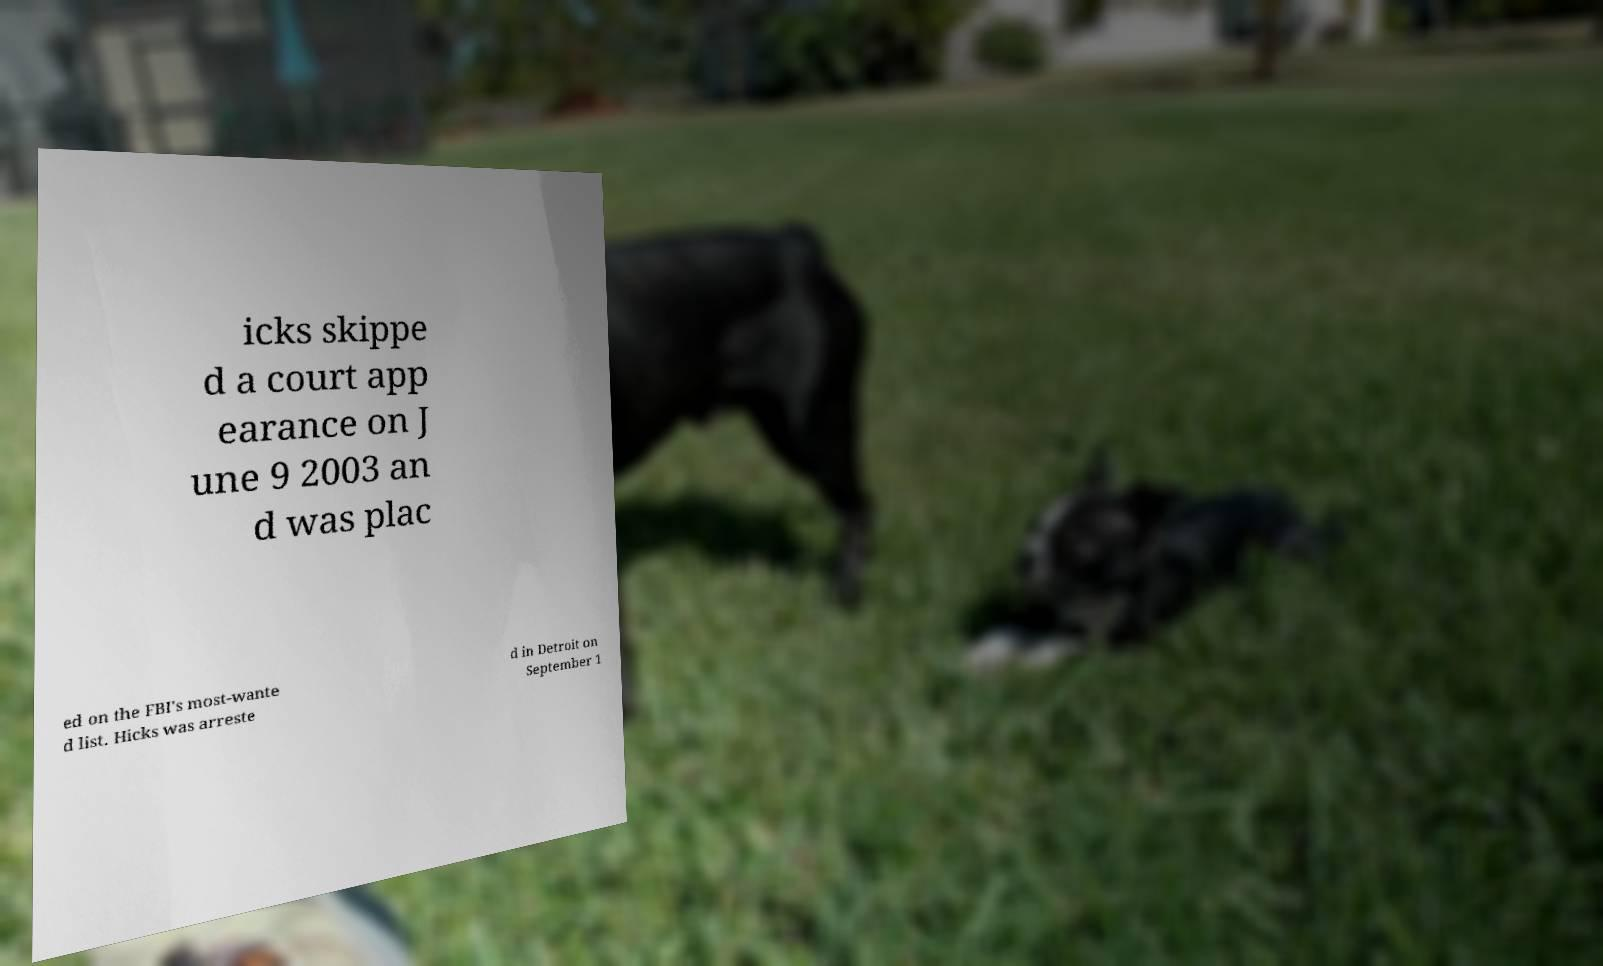Could you assist in decoding the text presented in this image and type it out clearly? icks skippe d a court app earance on J une 9 2003 an d was plac ed on the FBI's most-wante d list. Hicks was arreste d in Detroit on September 1 